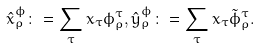Convert formula to latex. <formula><loc_0><loc_0><loc_500><loc_500>\hat { x } ^ { \phi } _ { \rho } \colon = \sum _ { \tau } x _ { \tau } \phi ^ { \tau } _ { \rho } , \hat { y } ^ { \phi } _ { \rho } \colon = \sum _ { \tau } x _ { \tau } \tilde { \phi } ^ { \tau } _ { \rho } .</formula> 